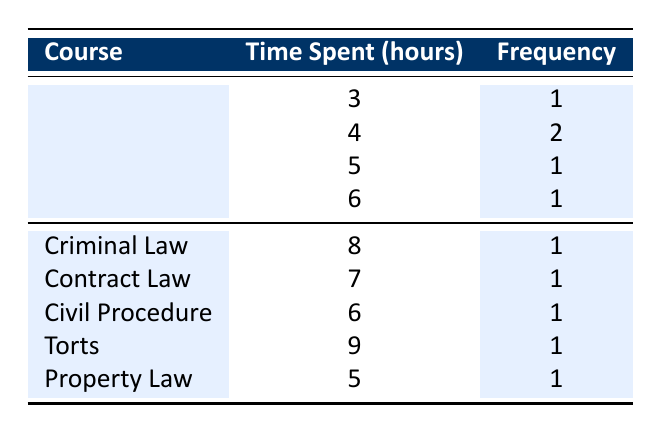What is the highest amount of time spent on an Ethical Theory assignment? By examining the "Time Spent (hours)" column under the Ethical Theory row, the maximum value listed is 6 hours.
Answer: 6 hours How many times did students spend 4 hours on Ethical Theory assignments? Referring to the frequency column, there are 2 occurrences of 4 hours spent on Ethical Theory assignments.
Answer: 2 times What is the total time spent on all coursework listed in the table? To find the total, we add the time spent for each course: 5 + 8 + 7 + 4 + 6 + 6 + 9 + 3 + 5 + 4 = 57 hours.
Answer: 57 hours Is there any course where students spent more hours compared to the maximum time spent on Ethical Theory? The maximum time for Ethical Theory is 6 hours. In the table, Torts shows a time spent of 9 hours, which is greater than 6 hours. Hence, the answer is yes.
Answer: Yes What is the average time spent on Ethical Theory assignments? To find the average for Ethical Theory, we sum the time spent: (3 + 4 + 4 + 5 + 6) = 22 hours and divide by the number of occurrences, which is 5. Thus, 22/5 = 4.4 hours average.
Answer: 4.4 hours Which course had the least time spent by students? By examining the course with the minimum time value, Ethical Theory shows 3 hours and it is the minimum compared to others.
Answer: Ethical Theory (3 hours) What is the difference in time spent between Torts and Criminal Law? Torts shows a time spent of 9 hours while Criminal Law shows 8 hours. The difference is 9 - 8 = 1 hour.
Answer: 1 hour How many courses have a total time spent of 6 hours or less? From the data, the courses with 6 hours or less are Ethical Theory (4, 4, 5, 3), Civil Procedure (6), and Property Law (5), totaling 6 courses.
Answer: 6 courses 